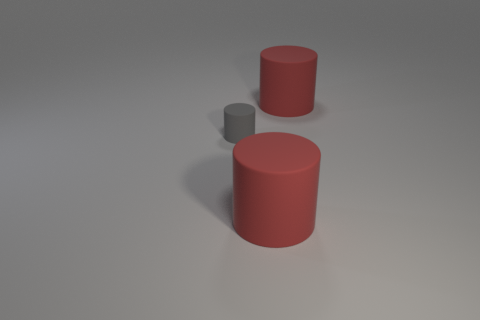Subtract all large matte cylinders. How many cylinders are left? 1 Subtract all red cylinders. How many cylinders are left? 1 Add 1 small things. How many objects exist? 4 Subtract all cyan cylinders. Subtract all green cubes. How many cylinders are left? 3 Subtract all brown cubes. How many gray cylinders are left? 1 Subtract all large red rubber objects. Subtract all small gray things. How many objects are left? 0 Add 3 small matte cylinders. How many small matte cylinders are left? 4 Add 3 metal cylinders. How many metal cylinders exist? 3 Subtract 1 gray cylinders. How many objects are left? 2 